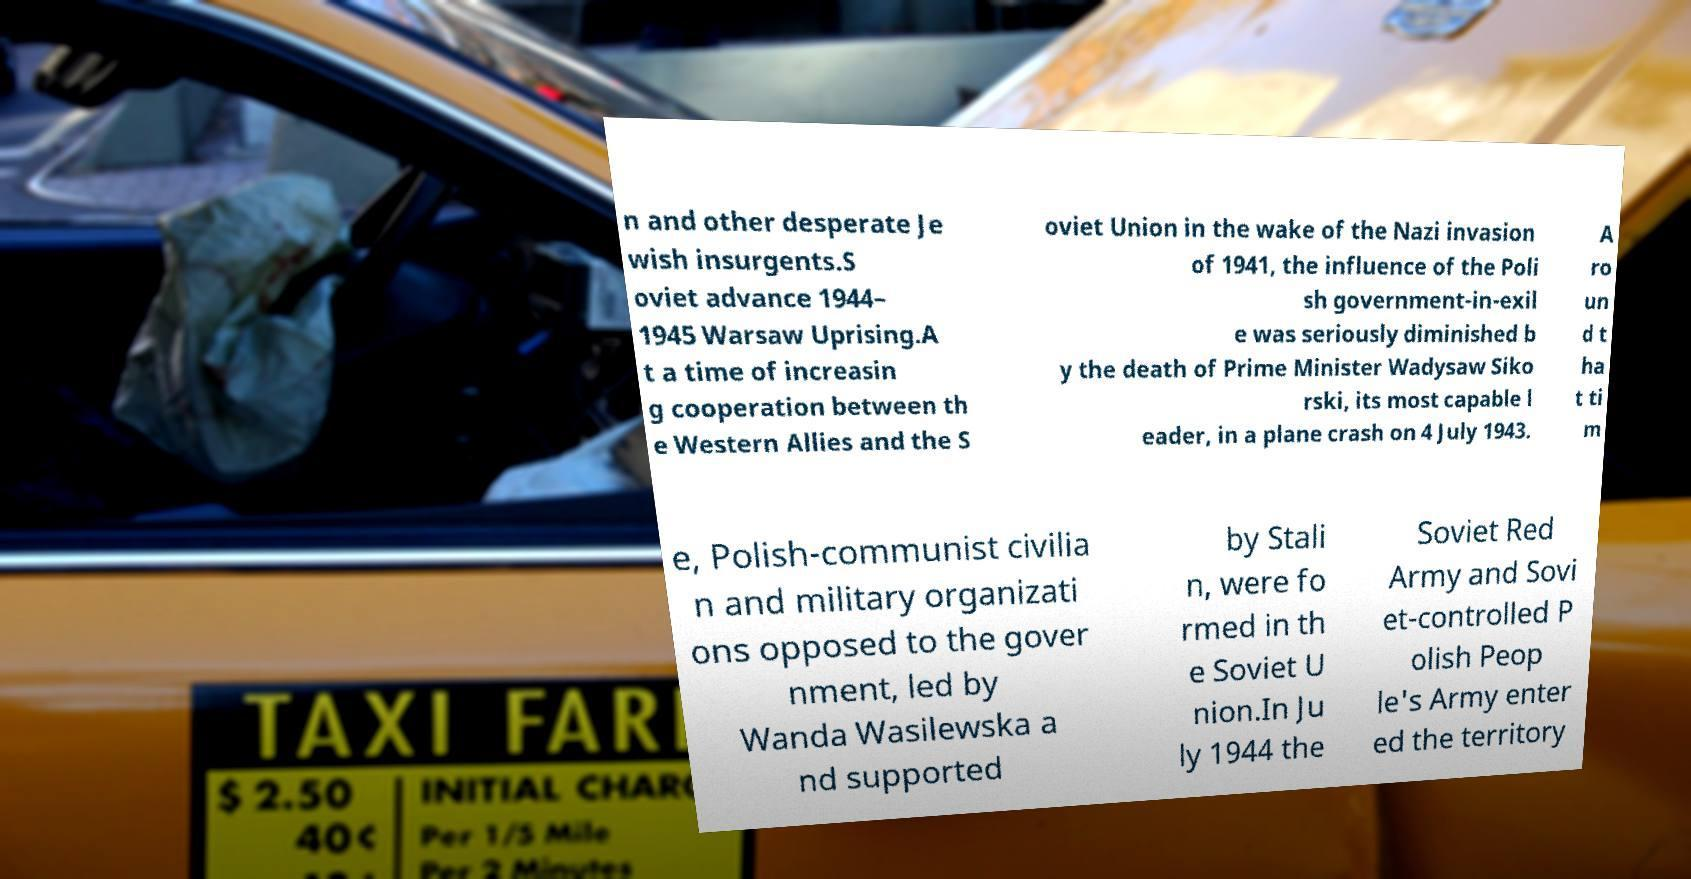There's text embedded in this image that I need extracted. Can you transcribe it verbatim? n and other desperate Je wish insurgents.S oviet advance 1944– 1945 Warsaw Uprising.A t a time of increasin g cooperation between th e Western Allies and the S oviet Union in the wake of the Nazi invasion of 1941, the influence of the Poli sh government-in-exil e was seriously diminished b y the death of Prime Minister Wadysaw Siko rski, its most capable l eader, in a plane crash on 4 July 1943. A ro un d t ha t ti m e, Polish-communist civilia n and military organizati ons opposed to the gover nment, led by Wanda Wasilewska a nd supported by Stali n, were fo rmed in th e Soviet U nion.In Ju ly 1944 the Soviet Red Army and Sovi et-controlled P olish Peop le's Army enter ed the territory 